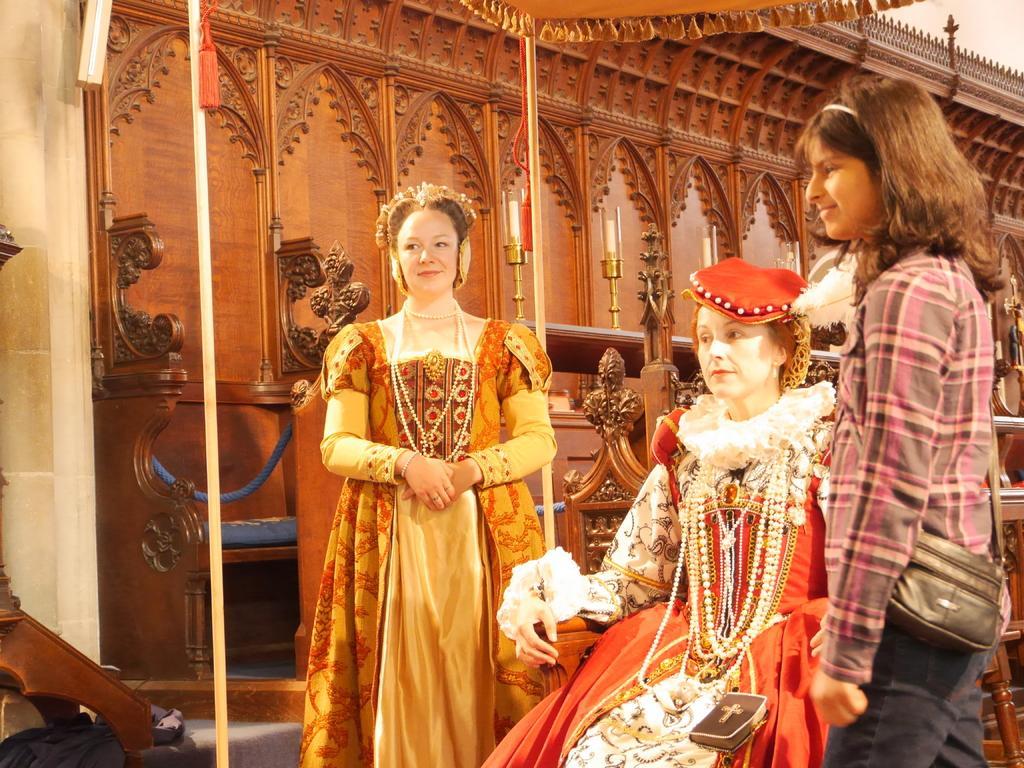Describe this image in one or two sentences. There are two women standing, in between these two women we can see another woman sitting on a chair. We can see poles. In the background we can see designed wall, candles, chair and ropes. 